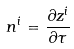<formula> <loc_0><loc_0><loc_500><loc_500>n ^ { i } = \frac { \partial z ^ { i } } { \partial \tau }</formula> 